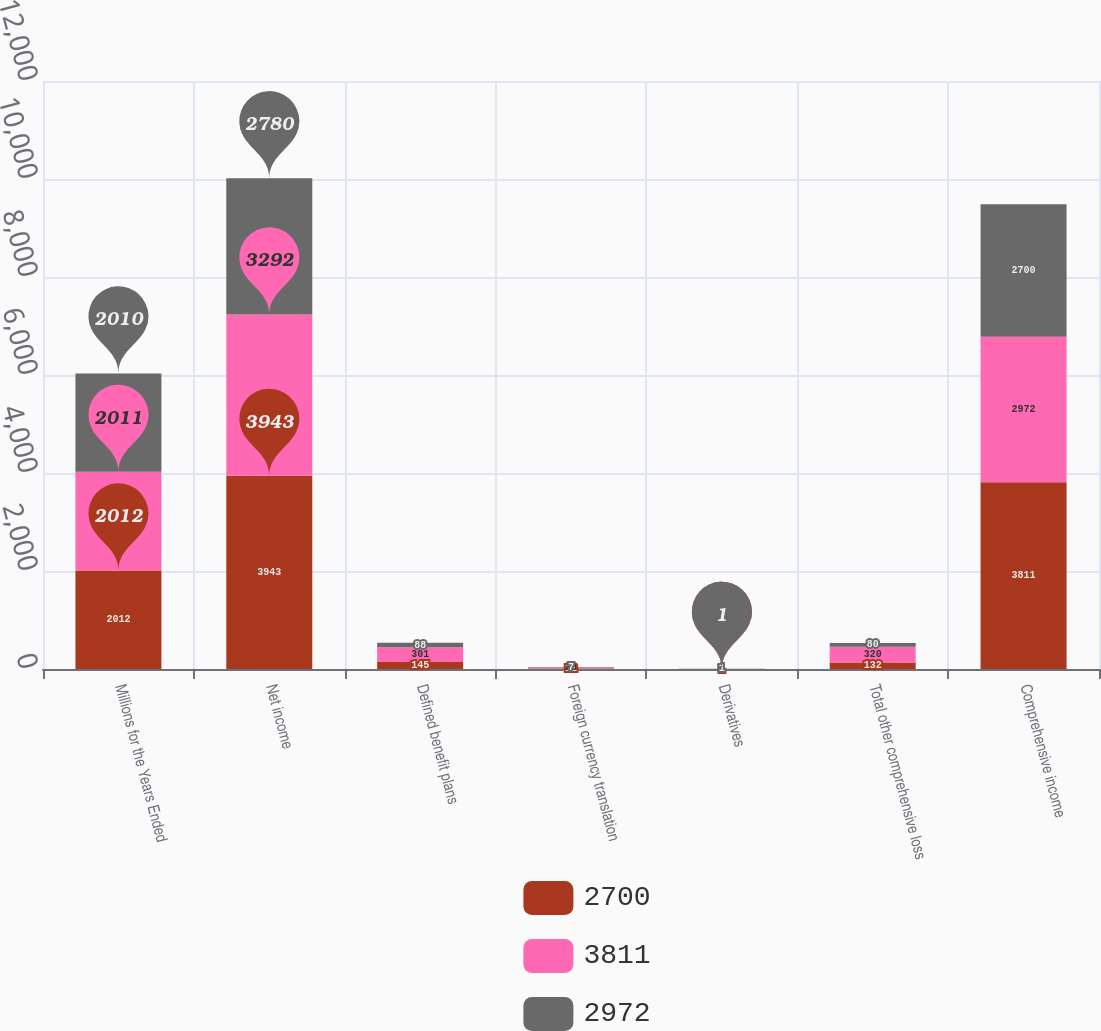Convert chart to OTSL. <chart><loc_0><loc_0><loc_500><loc_500><stacked_bar_chart><ecel><fcel>Millions for the Years Ended<fcel>Net income<fcel>Defined benefit plans<fcel>Foreign currency translation<fcel>Derivatives<fcel>Total other comprehensive loss<fcel>Comprehensive income<nl><fcel>2700<fcel>2012<fcel>3943<fcel>145<fcel>12<fcel>1<fcel>132<fcel>3811<nl><fcel>3811<fcel>2011<fcel>3292<fcel>301<fcel>20<fcel>1<fcel>320<fcel>2972<nl><fcel>2972<fcel>2010<fcel>2780<fcel>88<fcel>7<fcel>1<fcel>80<fcel>2700<nl></chart> 